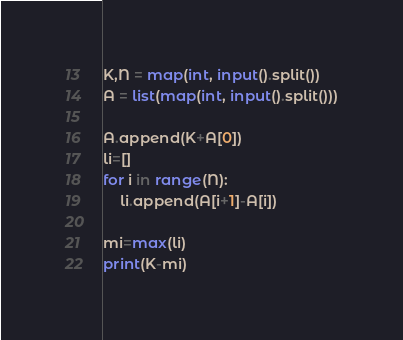Convert code to text. <code><loc_0><loc_0><loc_500><loc_500><_Python_>K,N = map(int, input().split())
A = list(map(int, input().split()))

A.append(K+A[0])
li=[]
for i in range(N):
    li.append(A[i+1]-A[i])

mi=max(li)
print(K-mi)
</code> 